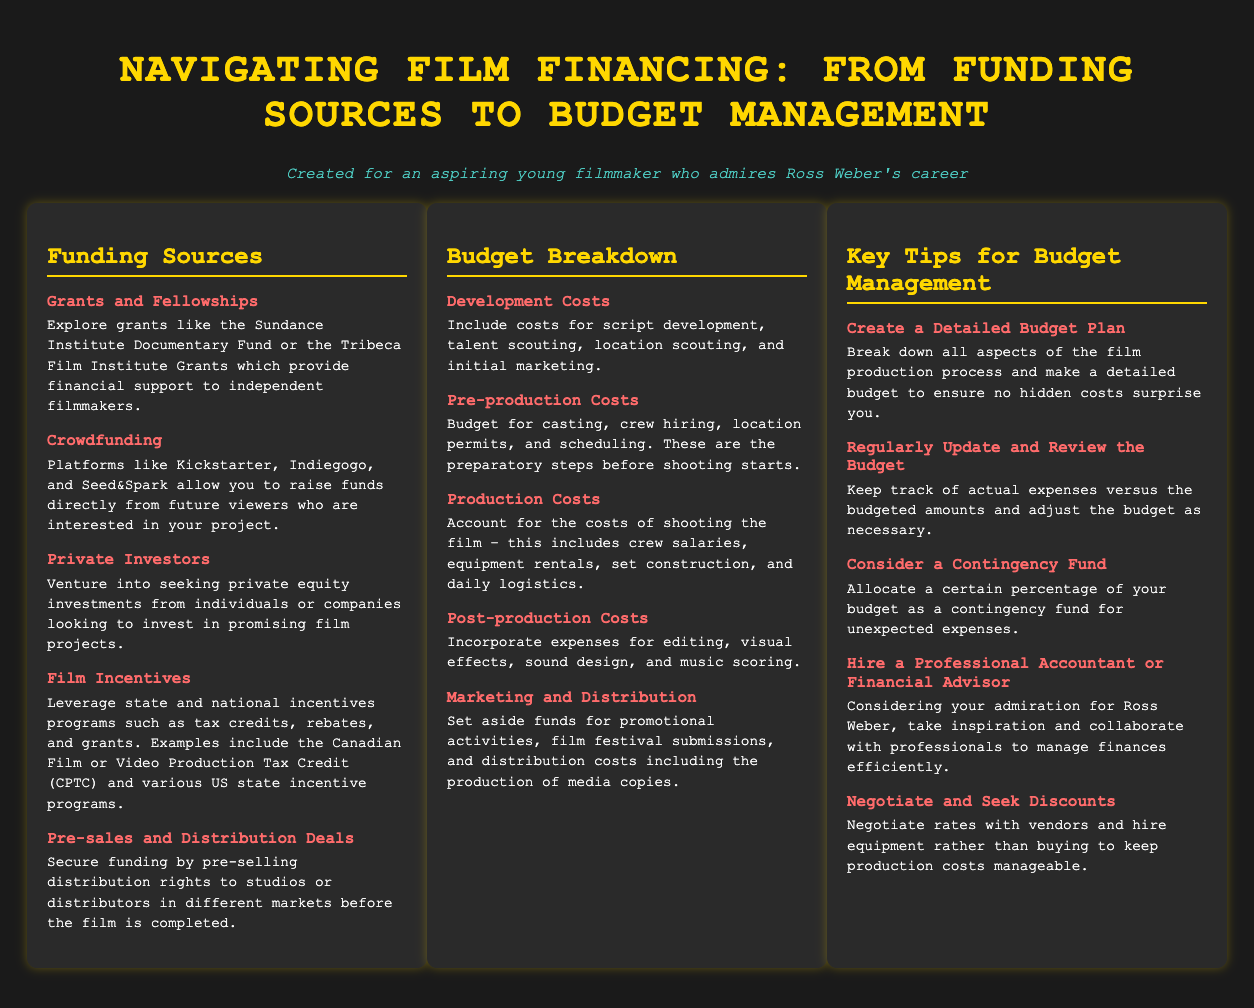What are some examples of grants? The document lists examples such as the Sundance Institute Documentary Fund and the Tribeca Film Institute Grants.
Answer: Sundance Institute Documentary Fund, Tribeca Film Institute Grants What is a way to secure funding before completion? The document states that pre-selling distribution rights is a method to secure funding before the film is completed.
Answer: Pre-sales and Distribution Deals What are the main categories of budget breakdown? The categories in the budget breakdown section include Development Costs, Pre-production Costs, Production Costs, Post-production Costs, and Marketing and Distribution.
Answer: Development Costs, Pre-production Costs, Production Costs, Post-production Costs, Marketing and Distribution What should you allocate as a contingency fund? The document suggests allocating a certain percentage of your budget as a contingency fund for unexpected expenses.
Answer: A certain percentage Which funding source involves future viewers? The document mentions crowdfunding, specifically naming platforms like Kickstarter and Indiegogo that allow you to raise funds from future viewers.
Answer: Crowdfunding Who should you consider hiring for budget management? The document recommends hiring a professional accountant or financial advisor for better management of finances.
Answer: Professional Accountant or Financial Advisor How should budget discrepancies be managed? The document advises regularly updating and reviewing the budget to account for actual expenses versus budgeted amounts.
Answer: Regularly Update and Review the Budget What is the purpose of budgeting for development costs? The document states that development costs include expenses for script development and initial marketing, among other preparatory expenses.
Answer: Script development and initial marketing What is one key tip for budget management? One key tip detailed in the document is to create a detailed budget plan to avoid surprises from hidden costs.
Answer: Create a Detailed Budget Plan 